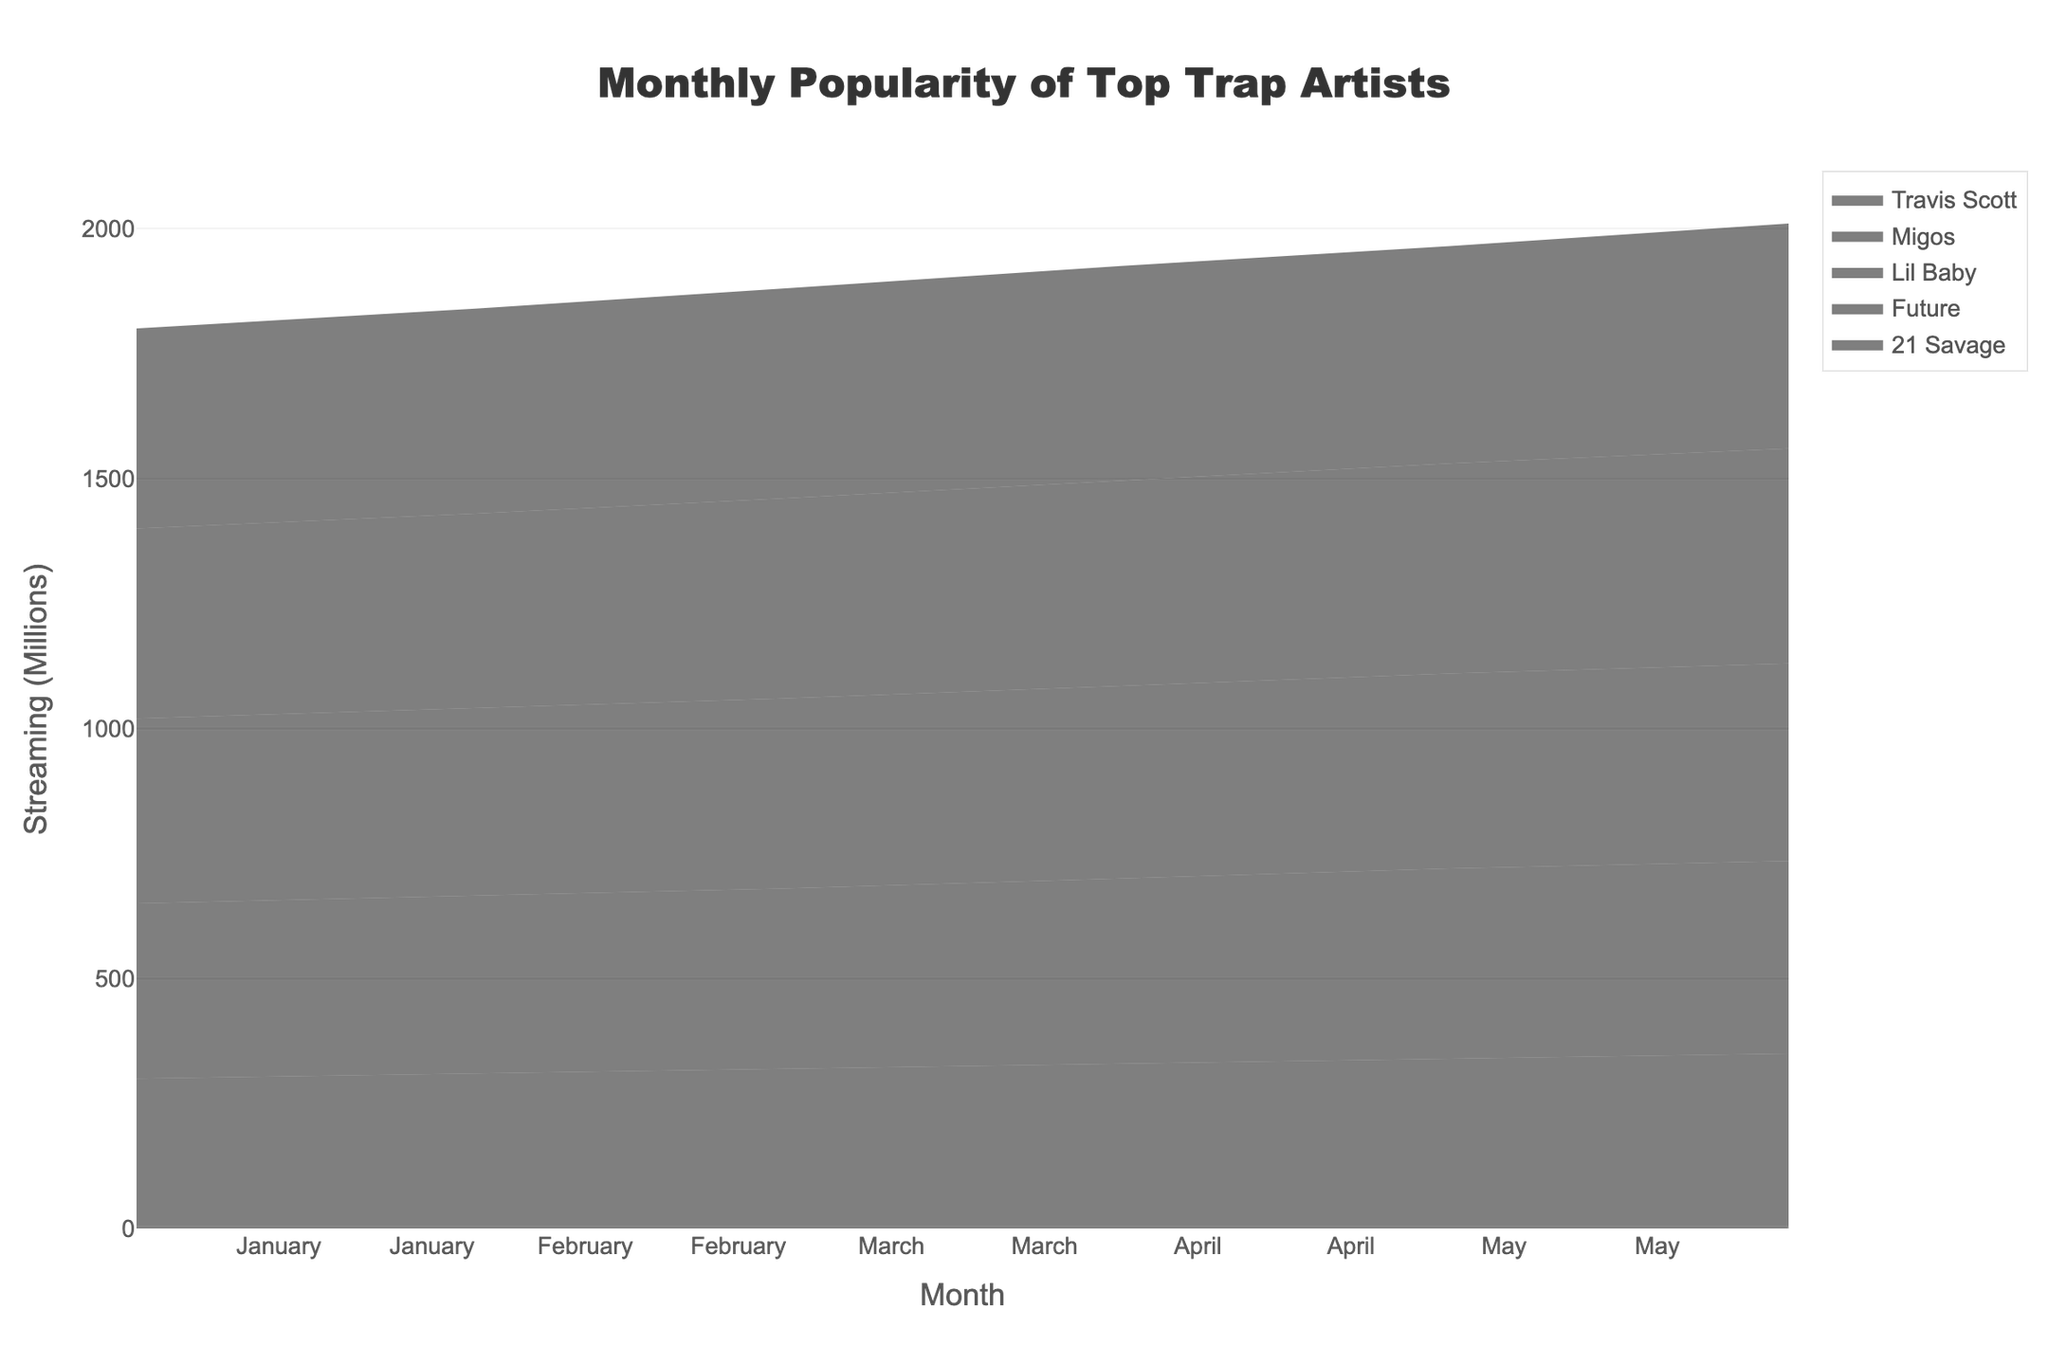what is the title of the figure? The title of the figure is located at the top and provides an overview of the content being visualized. In this case, it is "Monthly Popularity of Top Trap Artists."
Answer: Monthly Popularity of Top Trap Artists Which artist has the highest streaming number in June? The streams for each artist in June can be observed. The artist with the highest value is Travis Scott with 450 million streams.
Answer: Travis Scott How many artists are displayed in the stream graph? Each unique artist has its own section in the graph. By counting the distinct names, there are five unique artists displayed: Travis Scott, 21 Savage, Future, Migos, and Lil Baby.
Answer: 5 Which month saw the highest total streaming numbers for all the artists combined? To find this, sum up the streaming numbers for each artist per month and compare. June has the highest cumulative total with Travis Scott (450), 21 Savage (350), Future (385), Migos (430), and Lil Baby (395), giving a total of 2010 million streams.
Answer: June What is the general trend in social media engagement for all the artists? The social media engagement for each artist generally increases over the months, indicating a positive trend.
Answer: Increasing Who had a higher social media engagement in April, 21 Savage, or Lil Baby? By comparing the social media engagement of both artists for April: 21 Savage has 1550K and Lil Baby has 1710K. Lil Baby has the higher engagement.
Answer: Lil Baby Compare the growth in streaming numbers from February to March for Travis Scott and Migos. For Travis Scott: February (410) to March (420), growth is 10 million. For Migos: February (390) to March (400), growth is also 10 million. Both artists have the same growth.
Answer: Same What is the total social media engagement of Future across all months? Summing the social media engagements of Future from January to June: 1600 + 1610 + 1620 + 1650 + 1680 + 1750 = 9910K
Answer: 9910K Which artist's streaming metrics show the least variation over the months? Observing the differences in streaming figures month-to-month, Lil Baby shows the least variation, with relatively smaller increments compared to other artists.
Answer: Lil Baby How does Migos' streaming numbers in May compare to their streaming numbers in January? Migos' streaming numbers in May (420) are higher than in January (380). The difference is 40 million.
Answer: May is higher by 40 million 